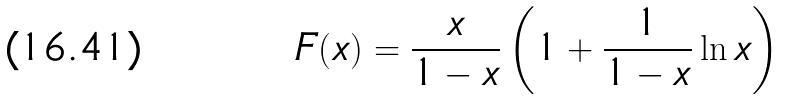Convert formula to latex. <formula><loc_0><loc_0><loc_500><loc_500>F ( x ) = \frac { x } { 1 - x } \left ( 1 + \frac { 1 } { 1 - x } \ln x \right )</formula> 